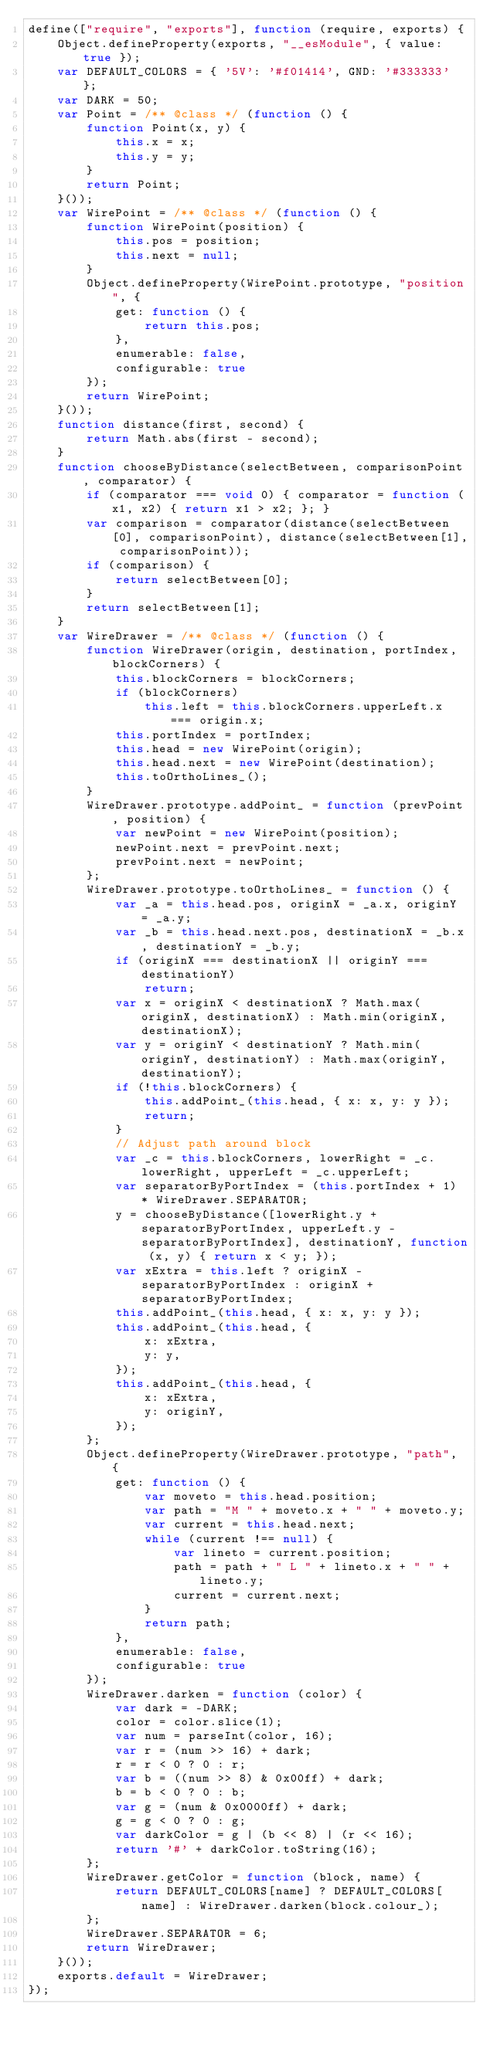<code> <loc_0><loc_0><loc_500><loc_500><_JavaScript_>define(["require", "exports"], function (require, exports) {
    Object.defineProperty(exports, "__esModule", { value: true });
    var DEFAULT_COLORS = { '5V': '#f01414', GND: '#333333' };
    var DARK = 50;
    var Point = /** @class */ (function () {
        function Point(x, y) {
            this.x = x;
            this.y = y;
        }
        return Point;
    }());
    var WirePoint = /** @class */ (function () {
        function WirePoint(position) {
            this.pos = position;
            this.next = null;
        }
        Object.defineProperty(WirePoint.prototype, "position", {
            get: function () {
                return this.pos;
            },
            enumerable: false,
            configurable: true
        });
        return WirePoint;
    }());
    function distance(first, second) {
        return Math.abs(first - second);
    }
    function chooseByDistance(selectBetween, comparisonPoint, comparator) {
        if (comparator === void 0) { comparator = function (x1, x2) { return x1 > x2; }; }
        var comparison = comparator(distance(selectBetween[0], comparisonPoint), distance(selectBetween[1], comparisonPoint));
        if (comparison) {
            return selectBetween[0];
        }
        return selectBetween[1];
    }
    var WireDrawer = /** @class */ (function () {
        function WireDrawer(origin, destination, portIndex, blockCorners) {
            this.blockCorners = blockCorners;
            if (blockCorners)
                this.left = this.blockCorners.upperLeft.x === origin.x;
            this.portIndex = portIndex;
            this.head = new WirePoint(origin);
            this.head.next = new WirePoint(destination);
            this.toOrthoLines_();
        }
        WireDrawer.prototype.addPoint_ = function (prevPoint, position) {
            var newPoint = new WirePoint(position);
            newPoint.next = prevPoint.next;
            prevPoint.next = newPoint;
        };
        WireDrawer.prototype.toOrthoLines_ = function () {
            var _a = this.head.pos, originX = _a.x, originY = _a.y;
            var _b = this.head.next.pos, destinationX = _b.x, destinationY = _b.y;
            if (originX === destinationX || originY === destinationY)
                return;
            var x = originX < destinationX ? Math.max(originX, destinationX) : Math.min(originX, destinationX);
            var y = originY < destinationY ? Math.min(originY, destinationY) : Math.max(originY, destinationY);
            if (!this.blockCorners) {
                this.addPoint_(this.head, { x: x, y: y });
                return;
            }
            // Adjust path around block
            var _c = this.blockCorners, lowerRight = _c.lowerRight, upperLeft = _c.upperLeft;
            var separatorByPortIndex = (this.portIndex + 1) * WireDrawer.SEPARATOR;
            y = chooseByDistance([lowerRight.y + separatorByPortIndex, upperLeft.y - separatorByPortIndex], destinationY, function (x, y) { return x < y; });
            var xExtra = this.left ? originX - separatorByPortIndex : originX + separatorByPortIndex;
            this.addPoint_(this.head, { x: x, y: y });
            this.addPoint_(this.head, {
                x: xExtra,
                y: y,
            });
            this.addPoint_(this.head, {
                x: xExtra,
                y: originY,
            });
        };
        Object.defineProperty(WireDrawer.prototype, "path", {
            get: function () {
                var moveto = this.head.position;
                var path = "M " + moveto.x + " " + moveto.y;
                var current = this.head.next;
                while (current !== null) {
                    var lineto = current.position;
                    path = path + " L " + lineto.x + " " + lineto.y;
                    current = current.next;
                }
                return path;
            },
            enumerable: false,
            configurable: true
        });
        WireDrawer.darken = function (color) {
            var dark = -DARK;
            color = color.slice(1);
            var num = parseInt(color, 16);
            var r = (num >> 16) + dark;
            r = r < 0 ? 0 : r;
            var b = ((num >> 8) & 0x00ff) + dark;
            b = b < 0 ? 0 : b;
            var g = (num & 0x0000ff) + dark;
            g = g < 0 ? 0 : g;
            var darkColor = g | (b << 8) | (r << 16);
            return '#' + darkColor.toString(16);
        };
        WireDrawer.getColor = function (block, name) {
            return DEFAULT_COLORS[name] ? DEFAULT_COLORS[name] : WireDrawer.darken(block.colour_);
        };
        WireDrawer.SEPARATOR = 6;
        return WireDrawer;
    }());
    exports.default = WireDrawer;
});
</code> 